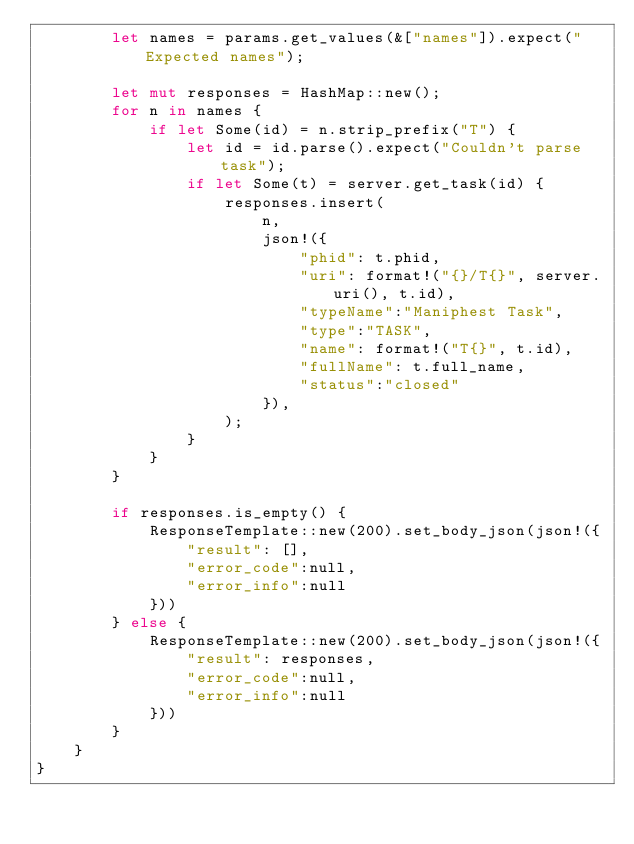<code> <loc_0><loc_0><loc_500><loc_500><_Rust_>        let names = params.get_values(&["names"]).expect("Expected names");

        let mut responses = HashMap::new();
        for n in names {
            if let Some(id) = n.strip_prefix("T") {
                let id = id.parse().expect("Couldn't parse task");
                if let Some(t) = server.get_task(id) {
                    responses.insert(
                        n,
                        json!({
                            "phid": t.phid,
                            "uri": format!("{}/T{}", server.uri(), t.id),
                            "typeName":"Maniphest Task",
                            "type":"TASK",
                            "name": format!("T{}", t.id),
                            "fullName": t.full_name,
                            "status":"closed"
                        }),
                    );
                }
            }
        }

        if responses.is_empty() {
            ResponseTemplate::new(200).set_body_json(json!({
                "result": [],
                "error_code":null,
                "error_info":null
            }))
        } else {
            ResponseTemplate::new(200).set_body_json(json!({
                "result": responses,
                "error_code":null,
                "error_info":null
            }))
        }
    }
}
</code> 